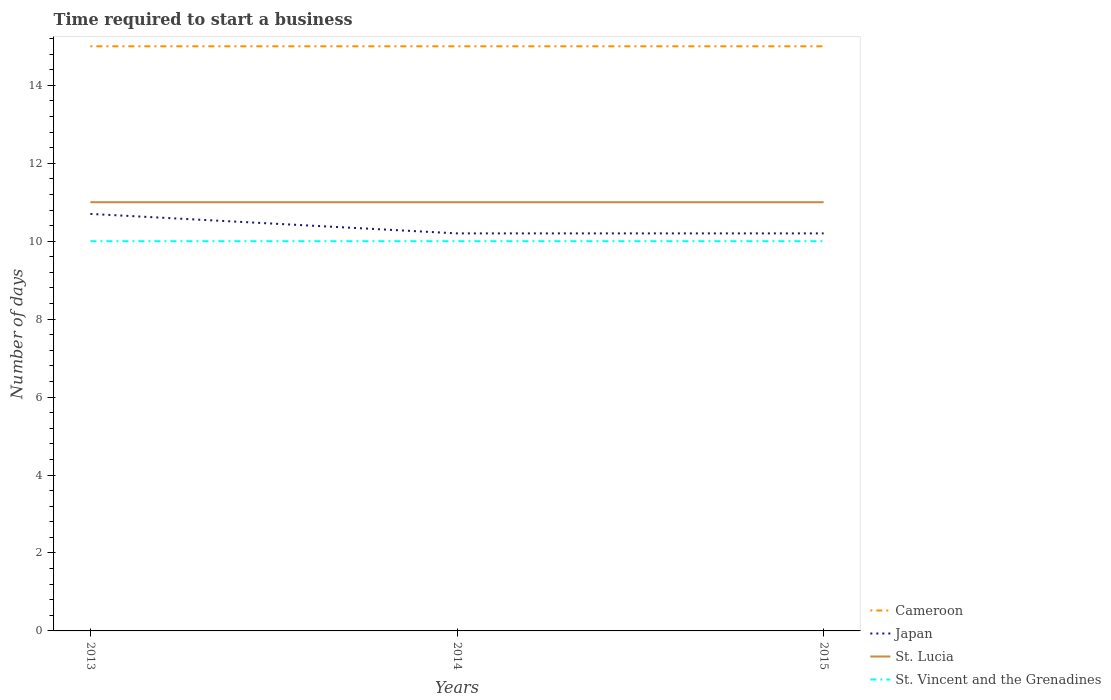Does the line corresponding to St. Vincent and the Grenadines intersect with the line corresponding to Cameroon?
Offer a terse response. No. Across all years, what is the maximum number of days required to start a business in St. Vincent and the Grenadines?
Make the answer very short. 10. What is the difference between the highest and the second highest number of days required to start a business in St. Lucia?
Your answer should be compact. 0. What is the difference between the highest and the lowest number of days required to start a business in Cameroon?
Offer a terse response. 0. Is the number of days required to start a business in St. Vincent and the Grenadines strictly greater than the number of days required to start a business in St. Lucia over the years?
Make the answer very short. Yes. How many lines are there?
Offer a very short reply. 4. What is the difference between two consecutive major ticks on the Y-axis?
Ensure brevity in your answer.  2. Are the values on the major ticks of Y-axis written in scientific E-notation?
Provide a succinct answer. No. Where does the legend appear in the graph?
Your response must be concise. Bottom right. How many legend labels are there?
Offer a terse response. 4. What is the title of the graph?
Your answer should be compact. Time required to start a business. Does "North America" appear as one of the legend labels in the graph?
Offer a terse response. No. What is the label or title of the Y-axis?
Offer a very short reply. Number of days. What is the Number of days of Japan in 2013?
Your answer should be very brief. 10.7. What is the Number of days in St. Vincent and the Grenadines in 2013?
Give a very brief answer. 10. Across all years, what is the maximum Number of days of Cameroon?
Ensure brevity in your answer.  15. Across all years, what is the maximum Number of days in Japan?
Ensure brevity in your answer.  10.7. Across all years, what is the maximum Number of days in St. Lucia?
Ensure brevity in your answer.  11. Across all years, what is the maximum Number of days of St. Vincent and the Grenadines?
Your response must be concise. 10. Across all years, what is the minimum Number of days in St. Vincent and the Grenadines?
Ensure brevity in your answer.  10. What is the total Number of days of Japan in the graph?
Offer a terse response. 31.1. What is the difference between the Number of days of Japan in 2013 and that in 2014?
Make the answer very short. 0.5. What is the difference between the Number of days of St. Lucia in 2013 and that in 2014?
Provide a short and direct response. 0. What is the difference between the Number of days of Cameroon in 2013 and that in 2015?
Ensure brevity in your answer.  0. What is the difference between the Number of days of Japan in 2013 and that in 2015?
Your answer should be very brief. 0.5. What is the difference between the Number of days of St. Vincent and the Grenadines in 2013 and that in 2015?
Your answer should be very brief. 0. What is the difference between the Number of days of Japan in 2014 and that in 2015?
Provide a succinct answer. 0. What is the difference between the Number of days in St. Lucia in 2014 and that in 2015?
Your response must be concise. 0. What is the difference between the Number of days in St. Vincent and the Grenadines in 2014 and that in 2015?
Provide a succinct answer. 0. What is the difference between the Number of days of St. Lucia in 2013 and the Number of days of St. Vincent and the Grenadines in 2014?
Offer a terse response. 1. What is the difference between the Number of days of Cameroon in 2013 and the Number of days of St. Vincent and the Grenadines in 2015?
Your answer should be very brief. 5. What is the difference between the Number of days of Japan in 2013 and the Number of days of St. Lucia in 2015?
Your answer should be compact. -0.3. What is the difference between the Number of days in Japan in 2013 and the Number of days in St. Vincent and the Grenadines in 2015?
Keep it short and to the point. 0.7. What is the difference between the Number of days in St. Lucia in 2013 and the Number of days in St. Vincent and the Grenadines in 2015?
Keep it short and to the point. 1. What is the difference between the Number of days of Cameroon in 2014 and the Number of days of Japan in 2015?
Provide a succinct answer. 4.8. What is the difference between the Number of days of Japan in 2014 and the Number of days of St. Lucia in 2015?
Your response must be concise. -0.8. What is the average Number of days in Cameroon per year?
Keep it short and to the point. 15. What is the average Number of days in Japan per year?
Ensure brevity in your answer.  10.37. In the year 2014, what is the difference between the Number of days of Cameroon and Number of days of St. Lucia?
Provide a short and direct response. 4. In the year 2014, what is the difference between the Number of days of Cameroon and Number of days of St. Vincent and the Grenadines?
Your response must be concise. 5. In the year 2014, what is the difference between the Number of days in St. Lucia and Number of days in St. Vincent and the Grenadines?
Ensure brevity in your answer.  1. What is the ratio of the Number of days of Cameroon in 2013 to that in 2014?
Keep it short and to the point. 1. What is the ratio of the Number of days in Japan in 2013 to that in 2014?
Offer a terse response. 1.05. What is the ratio of the Number of days of Cameroon in 2013 to that in 2015?
Provide a short and direct response. 1. What is the ratio of the Number of days in Japan in 2013 to that in 2015?
Offer a very short reply. 1.05. What is the ratio of the Number of days of St. Vincent and the Grenadines in 2013 to that in 2015?
Make the answer very short. 1. What is the ratio of the Number of days of St. Vincent and the Grenadines in 2014 to that in 2015?
Your response must be concise. 1. What is the difference between the highest and the lowest Number of days in Cameroon?
Provide a short and direct response. 0. What is the difference between the highest and the lowest Number of days of Japan?
Give a very brief answer. 0.5. What is the difference between the highest and the lowest Number of days in St. Vincent and the Grenadines?
Keep it short and to the point. 0. 